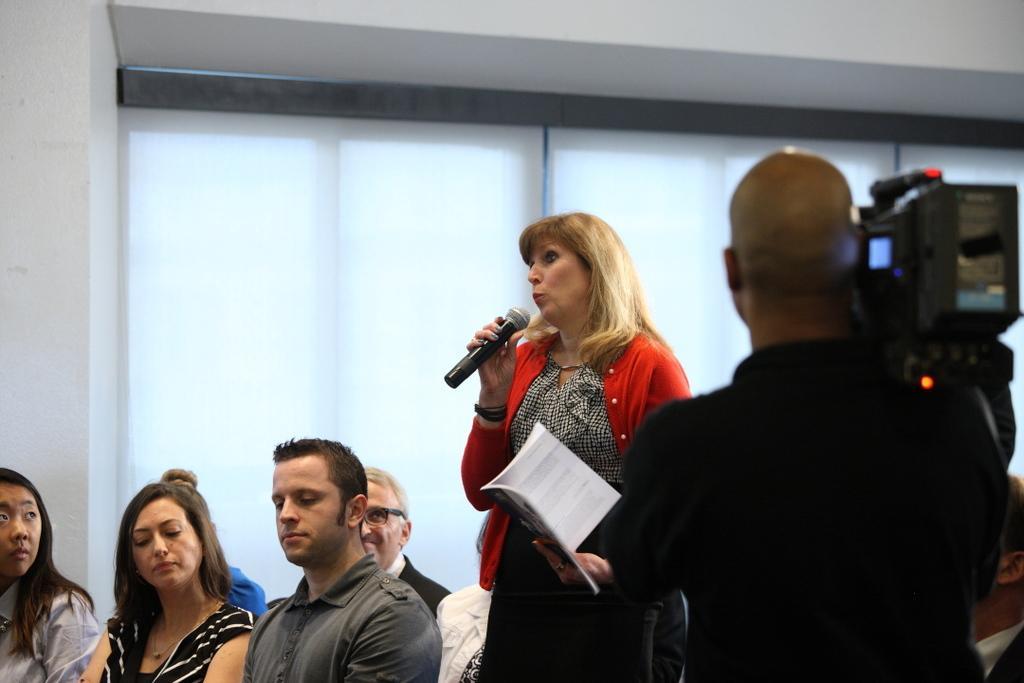Could you give a brief overview of what you see in this image? In this picture there is a woman holding a book and a mic in her hands , standing and talking. There is a man taking the video of it and some of the people were sitting and listening to her. In the background there is a wall and Windows here along with curtains. 